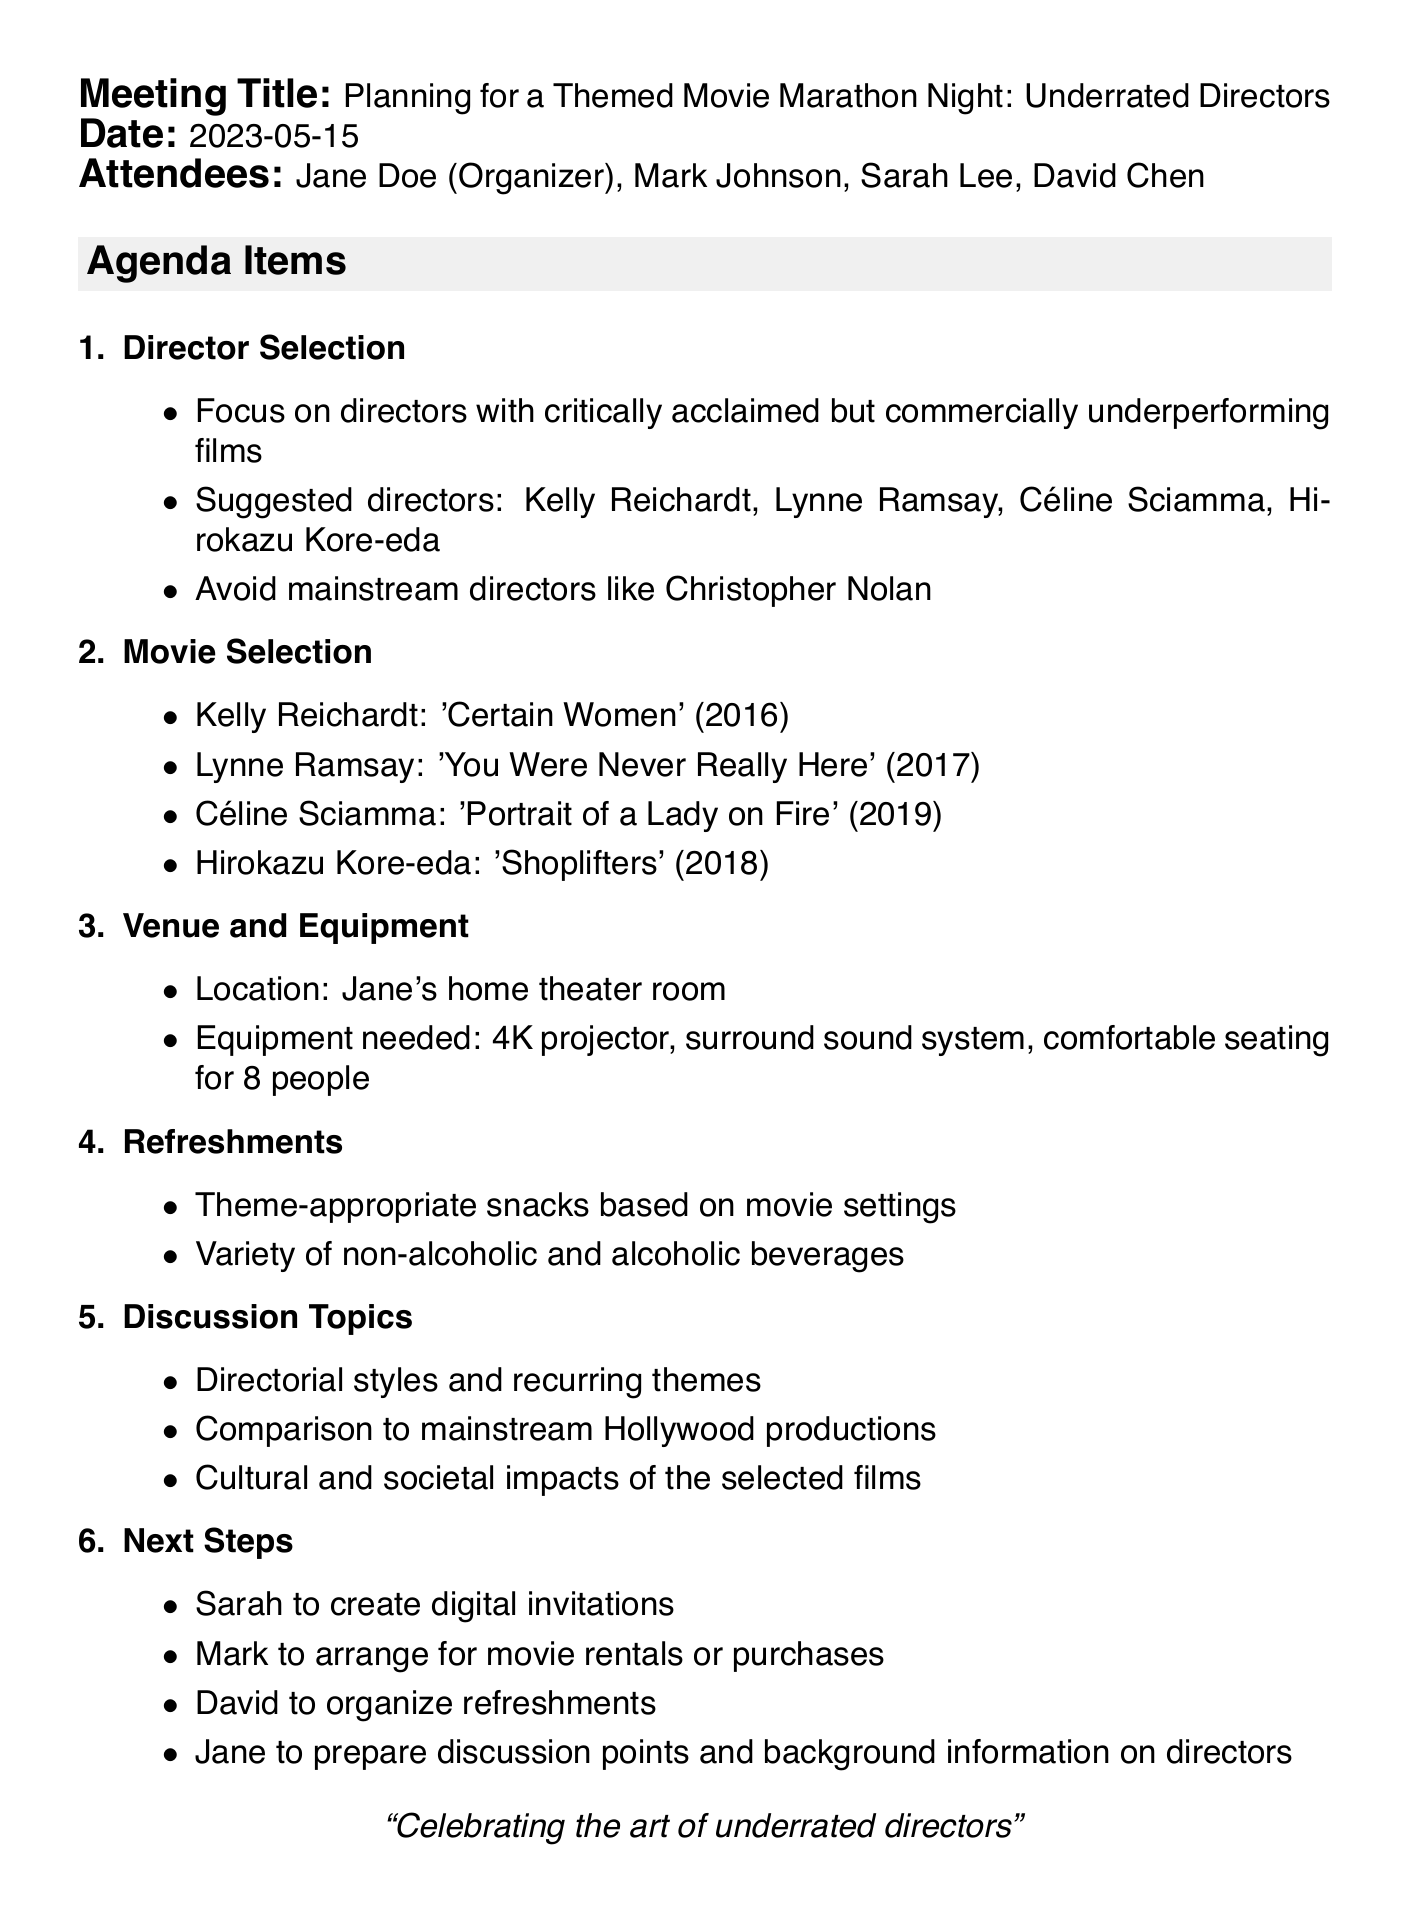What is the meeting title? The meeting title is stated in the introduction of the document, indicating the purpose of the meeting.
Answer: Planning for a Themed Movie Marathon Night: Underrated Directors What is the date of the meeting? The date is clearly mentioned right after the meeting title, providing a specific timeframe for the event.
Answer: 2023-05-15 Who is organizing the event? The organizer is listed among the attendees, indicating who is responsible for planning the event.
Answer: Jane Doe What are the suggested directors? The suggested directors are provided in the Director Selection section, listing individuals who fit the theme of the marathon.
Answer: Kelly Reichardt, Lynne Ramsay, Céline Sciamma, Hirokazu Kore-eda What film is associated with Lynne Ramsay? The film associated with Lynne Ramsay can be found in the Movie Selection section, detailing one of the chosen movies for the marathon.
Answer: You Were Never Really Here (2017) What is the venue for the marathon night? The venue is specified in the Venue and Equipment section, indicating where the event will take place.
Answer: Jane's home theater room Who is responsible for creating digital invitations? The responsibility for digital invitations is outlined in the Next Steps section, detailing who will carry out this task.
Answer: Sarah How many people can be comfortably seated? The seating capacity is mentioned under the Venue and Equipment section, providing information on the space available for attendees.
Answer: 8 people What type of drinks will be served? The refreshments section mentions the variety of drinks, indicating what options will be available during the event.
Answer: Non-alcoholic and alcoholic beverages 